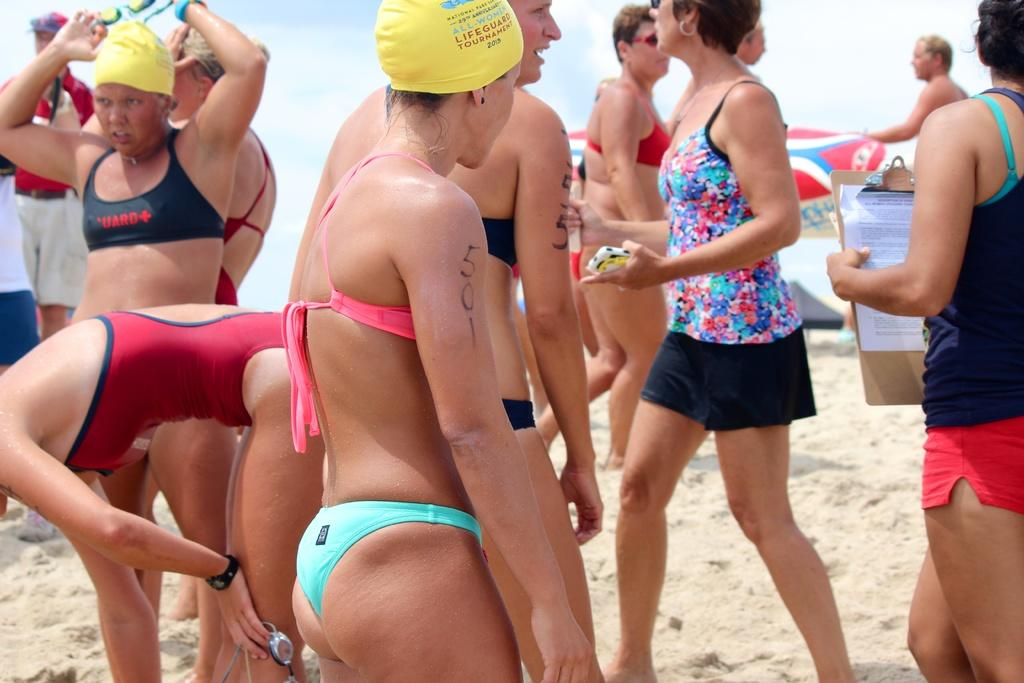How many people are present in the image? There are many people in the image. What are some of the people doing in the image? Some people are holding objects in their hands. What is the setting of the image? There is a beach in the image. What type of scissors can be seen being used on the beach in the image? There are no scissors present in the image. How many shoes are visible on the beach in the image? There is no mention of shoes in the image, as it focuses on the people and their actions. 